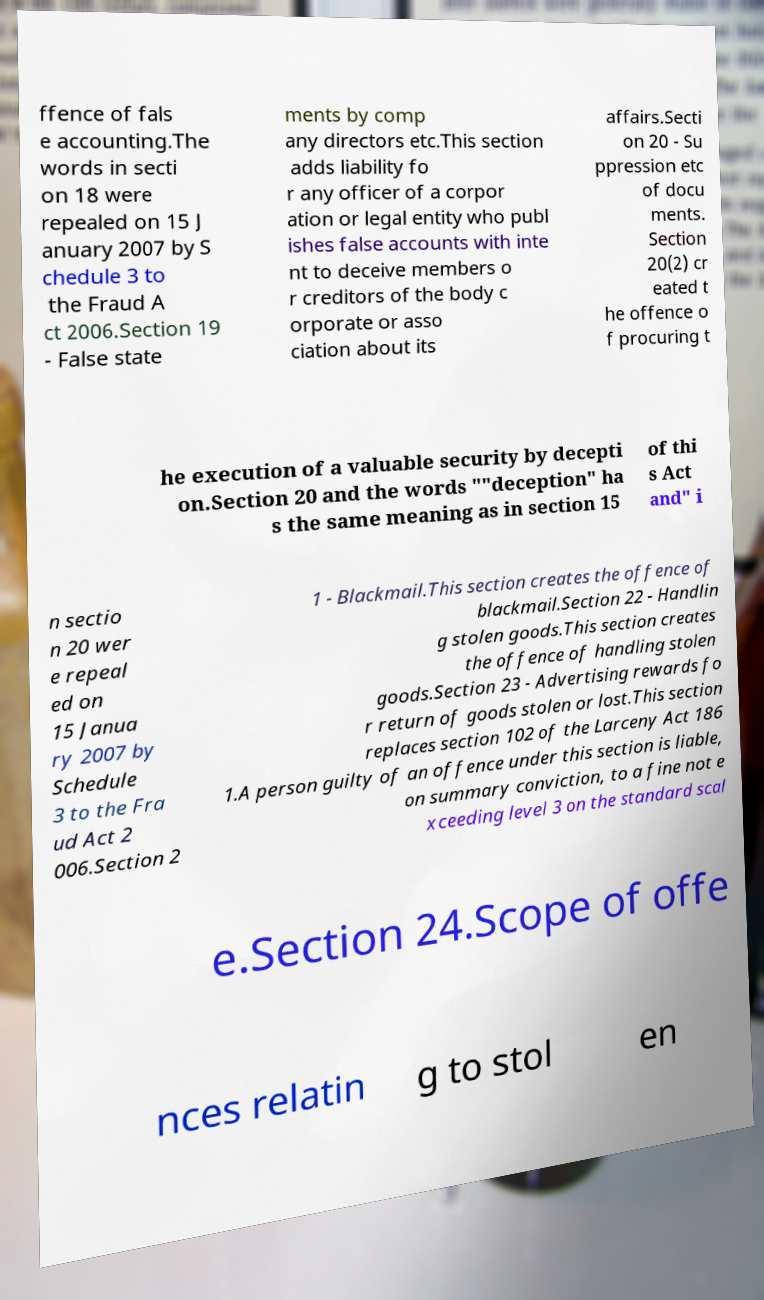Please identify and transcribe the text found in this image. ffence of fals e accounting.The words in secti on 18 were repealed on 15 J anuary 2007 by S chedule 3 to the Fraud A ct 2006.Section 19 - False state ments by comp any directors etc.This section adds liability fo r any officer of a corpor ation or legal entity who publ ishes false accounts with inte nt to deceive members o r creditors of the body c orporate or asso ciation about its affairs.Secti on 20 - Su ppression etc of docu ments. Section 20(2) cr eated t he offence o f procuring t he execution of a valuable security by decepti on.Section 20 and the words ""deception" ha s the same meaning as in section 15 of thi s Act and" i n sectio n 20 wer e repeal ed on 15 Janua ry 2007 by Schedule 3 to the Fra ud Act 2 006.Section 2 1 - Blackmail.This section creates the offence of blackmail.Section 22 - Handlin g stolen goods.This section creates the offence of handling stolen goods.Section 23 - Advertising rewards fo r return of goods stolen or lost.This section replaces section 102 of the Larceny Act 186 1.A person guilty of an offence under this section is liable, on summary conviction, to a fine not e xceeding level 3 on the standard scal e.Section 24.Scope of offe nces relatin g to stol en 